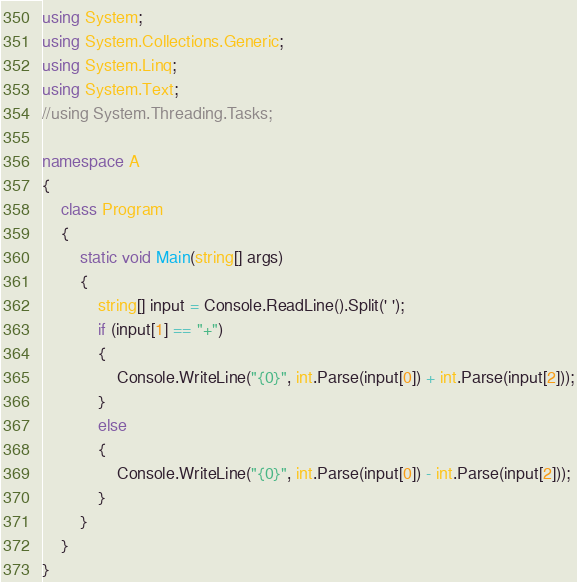Convert code to text. <code><loc_0><loc_0><loc_500><loc_500><_C#_>using System;
using System.Collections.Generic;
using System.Linq;
using System.Text;
//using System.Threading.Tasks;

namespace A
{
    class Program
    {
        static void Main(string[] args)
        {
            string[] input = Console.ReadLine().Split(' ');
            if (input[1] == "+")
            {
                Console.WriteLine("{0}", int.Parse(input[0]) + int.Parse(input[2]));
            }
            else
            {
                Console.WriteLine("{0}", int.Parse(input[0]) - int.Parse(input[2]));
            }
        }
    }
}
</code> 